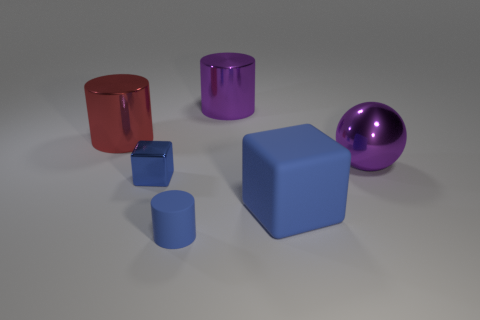There is a large ball; is its color the same as the large shiny thing behind the big red metallic cylinder?
Give a very brief answer. Yes. There is a object that is behind the large matte thing and in front of the ball; what material is it?
Keep it short and to the point. Metal. The matte cube that is the same color as the matte cylinder is what size?
Ensure brevity in your answer.  Large. Do the large thing in front of the blue metal thing and the purple metallic thing that is right of the large matte cube have the same shape?
Offer a very short reply. No. Is there a gray object?
Give a very brief answer. No. There is another metal thing that is the same shape as the large red shiny thing; what color is it?
Offer a terse response. Purple. What color is the metal cylinder that is the same size as the red metallic object?
Your answer should be very brief. Purple. Do the purple cylinder and the blue cylinder have the same material?
Your response must be concise. No. What number of matte cubes are the same color as the small cylinder?
Offer a very short reply. 1. Is the color of the shiny cube the same as the tiny cylinder?
Provide a succinct answer. Yes. 